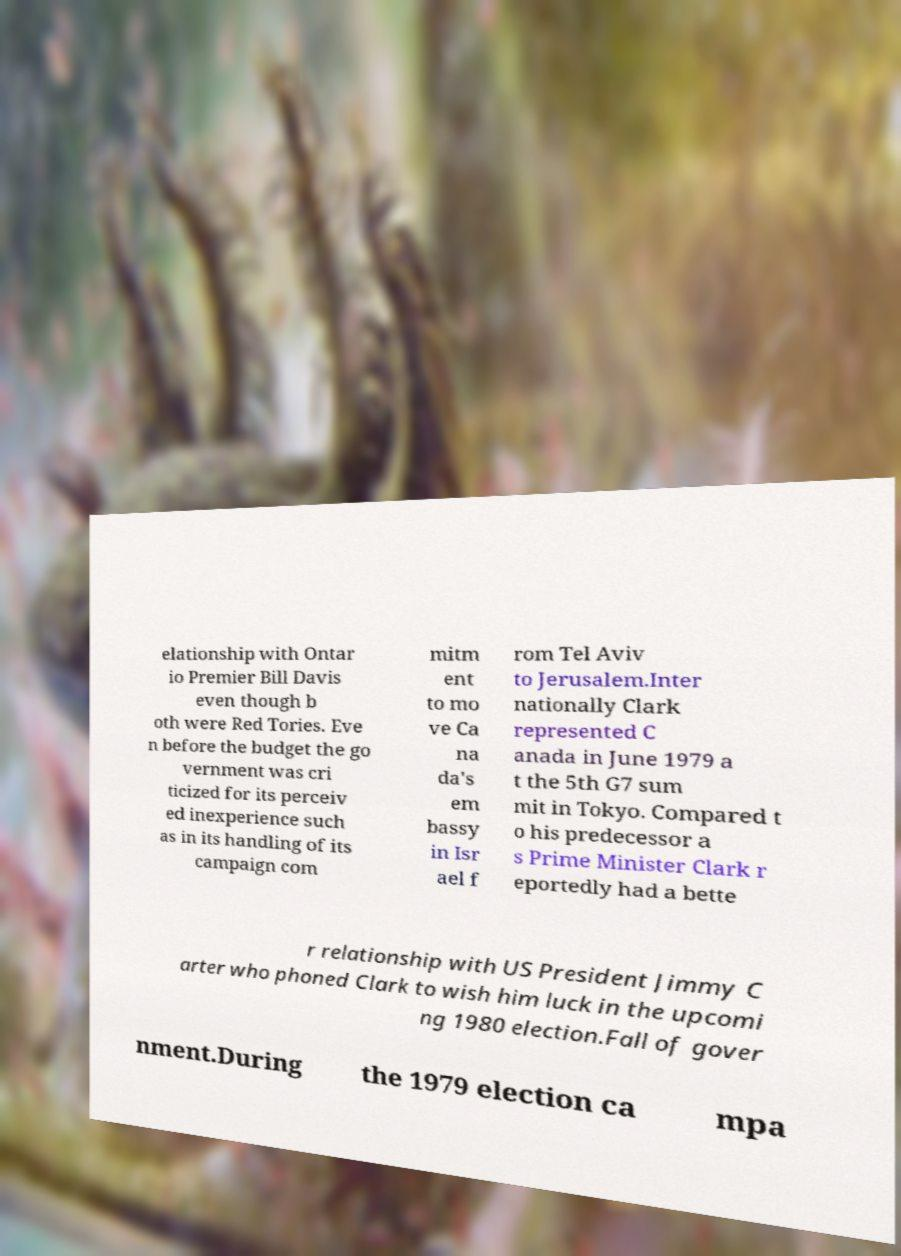I need the written content from this picture converted into text. Can you do that? elationship with Ontar io Premier Bill Davis even though b oth were Red Tories. Eve n before the budget the go vernment was cri ticized for its perceiv ed inexperience such as in its handling of its campaign com mitm ent to mo ve Ca na da's em bassy in Isr ael f rom Tel Aviv to Jerusalem.Inter nationally Clark represented C anada in June 1979 a t the 5th G7 sum mit in Tokyo. Compared t o his predecessor a s Prime Minister Clark r eportedly had a bette r relationship with US President Jimmy C arter who phoned Clark to wish him luck in the upcomi ng 1980 election.Fall of gover nment.During the 1979 election ca mpa 